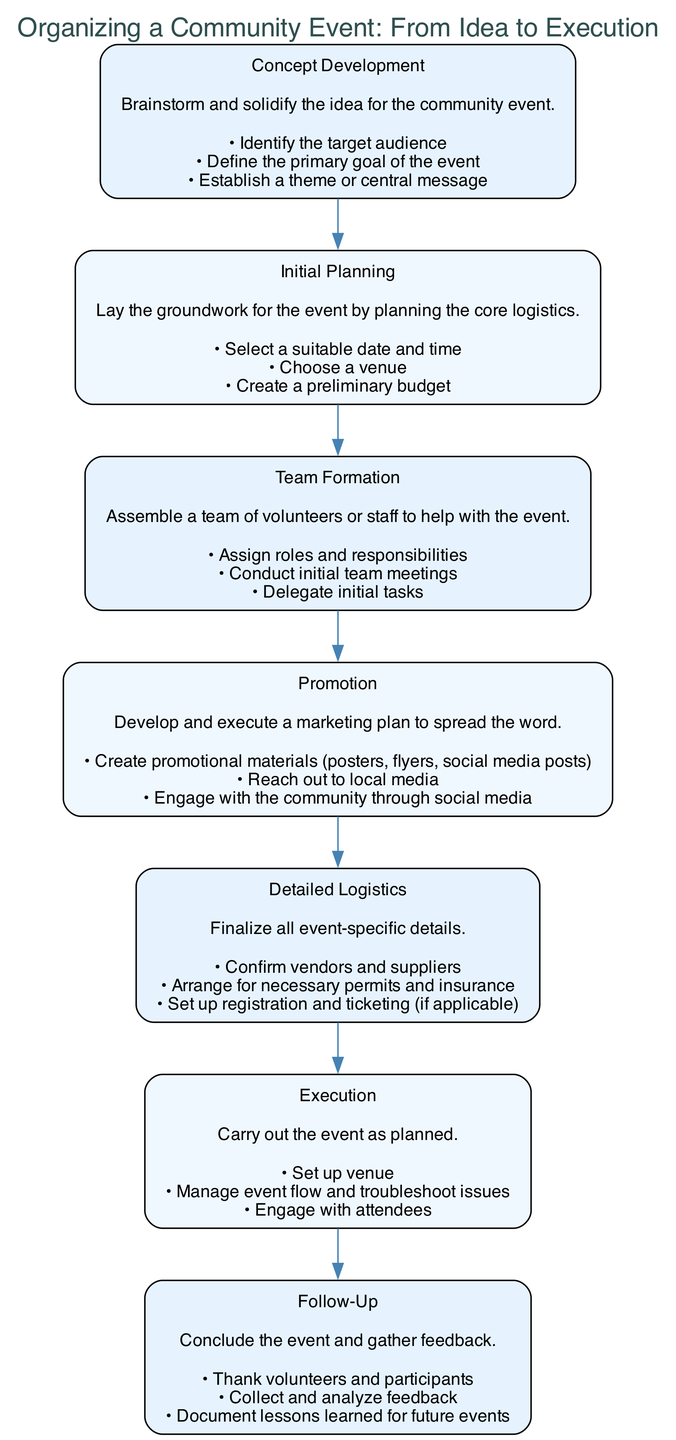What is the first step in organizing a community event? The first step in the diagram is labeled "Concept Development," which is the initial phase for brainstorming and solidifying the idea for the event.
Answer: Concept Development How many tasks are involved in the "Promotion" step? In the "Promotion" step, there are three distinct tasks listed: creating promotional materials, reaching out to local media, and engaging with the community through social media.
Answer: 3 Which step follows "Team Formation"? The diagram shows that "Promotion" directly follows "Team Formation," indicating the next logical action after assembling the team is marketing the event.
Answer: Promotion What is the primary goal outlined in the "Concept Development" phase? The main goal is defined in the "Concept Development" phase, where the primary goal of the event is established, though the specific goal is not provided in the excerpt.
Answer: Define the primary goal of the event Which two steps are connected by an edge in the flowchart? In reviewing the flowchart, multiple steps are connected by edges, specifically, "Initial Planning" has an edge connecting it to "Team Formation," showing a direct progression from planning to team assembly.
Answer: Initial Planning to Team Formation What is the last step in the event organization process? The last step presented in the flowchart is labeled "Follow-Up," which consists of concluding the event and gathering feedback post-execution.
Answer: Follow-Up Name one task involved in "Detailed Logistics." Within the "Detailed Logistics" step, one task is "Confirm vendors and suppliers," demonstrating a key aspect of finalizing the event's details.
Answer: Confirm vendors and suppliers How many overall steps are shown in the flowchart? The diagram indicates a total of seven steps, each representing a different phase in the process of organizing a community event from idea to execution.
Answer: 7 What type of feedback is gathered in the "Follow-Up" stage? In the "Follow-Up" stage, the feedback collected is aimed at analyzing responses and documenting lessons learned for improvement in future events.
Answer: Analyze feedback and document lessons learned 